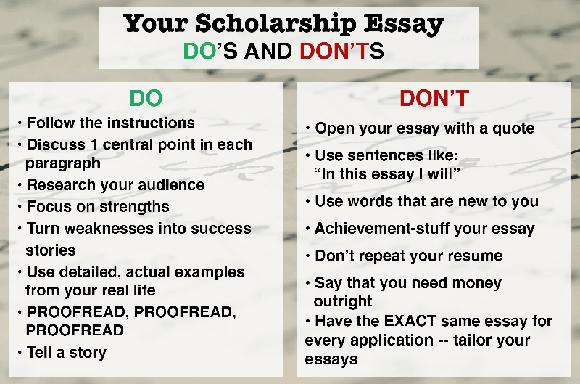What are some of the DO's mentioned for writing a scholarship essay? For an effective scholarship essay, always adhere to the provided instructions to ensure alignment with the criteria. Strategically discuss one central idea per paragraph to maintain clarity and coherence. Thoroughly research your audience to tailor your content to their interests. Emphasize your strengths and creatively turn any weaknesses into narratives of personal growth and resilience. Incorporate detailed, specific examples from your personal experiences to add authenticity and relatability. Always proofread your essay multiple times to eliminate errors and refine its structure. Lastly, engage your readers by crafting your essay into a compelling narrative that illustrates your journey or perspectives. 